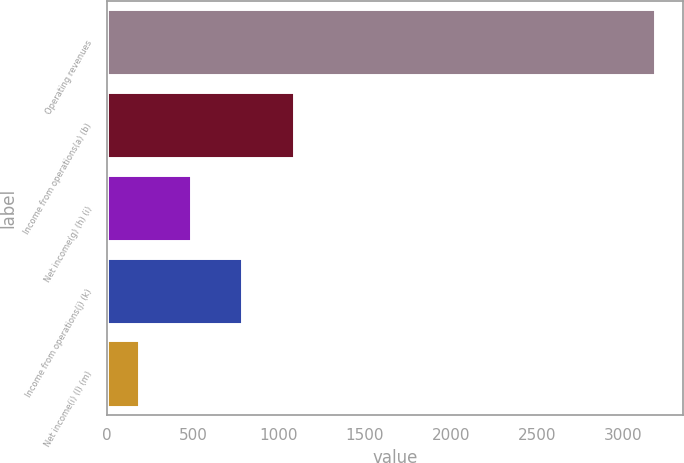<chart> <loc_0><loc_0><loc_500><loc_500><bar_chart><fcel>Operating revenues<fcel>Income from operations(a) (b)<fcel>Net income(g) (h) (i)<fcel>Income from operations(j) (k)<fcel>Net income(i) (l) (m)<nl><fcel>3188<fcel>1086.6<fcel>486.2<fcel>786.4<fcel>186<nl></chart> 